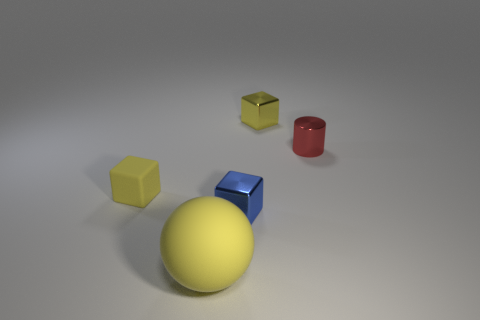What is the shape of the shiny thing that is the same color as the big sphere?
Keep it short and to the point. Cube. There is a red shiny thing; is it the same shape as the tiny yellow thing that is to the right of the tiny blue metal thing?
Your answer should be very brief. No. There is a yellow matte object that is to the left of the yellow ball; is it the same size as the shiny thing that is in front of the tiny yellow matte cube?
Provide a succinct answer. Yes. There is a rubber thing behind the big yellow ball that is to the left of the blue metallic object; are there any tiny yellow blocks that are on the right side of it?
Provide a succinct answer. Yes. Are there fewer tiny blocks that are in front of the blue shiny block than metal things in front of the matte block?
Your response must be concise. Yes. There is a small object that is made of the same material as the yellow sphere; what is its shape?
Provide a succinct answer. Cube. How big is the shiny object that is in front of the tiny metallic object that is on the right side of the tiny yellow metallic block that is behind the big ball?
Ensure brevity in your answer.  Small. Are there more small red things than matte things?
Provide a short and direct response. No. Does the tiny cube left of the tiny blue shiny cube have the same color as the object in front of the blue metallic cube?
Provide a short and direct response. Yes. Are the yellow cube that is in front of the small red thing and the tiny yellow cube behind the red metallic cylinder made of the same material?
Your answer should be very brief. No. 